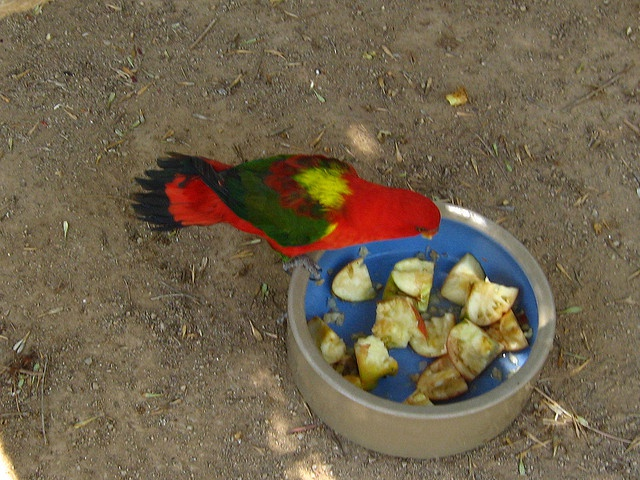Describe the objects in this image and their specific colors. I can see bowl in tan, gray, and olive tones, bird in tan, black, brown, and maroon tones, apple in tan, olive, and khaki tones, apple in tan and olive tones, and apple in tan, olive, maroon, and gray tones in this image. 